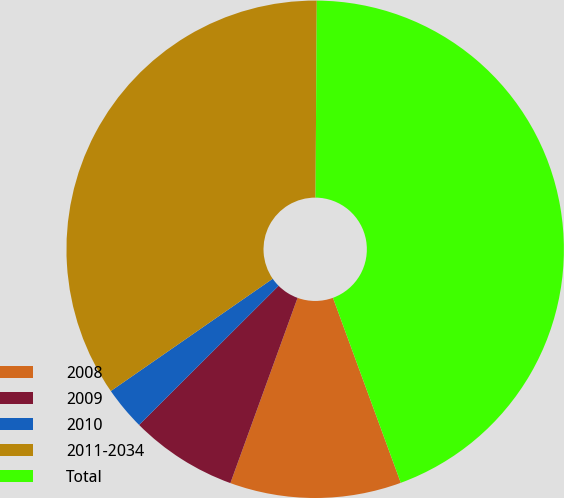Convert chart. <chart><loc_0><loc_0><loc_500><loc_500><pie_chart><fcel>2008<fcel>2009<fcel>2010<fcel>2011-2034<fcel>Total<nl><fcel>11.13%<fcel>6.98%<fcel>2.83%<fcel>34.75%<fcel>44.3%<nl></chart> 